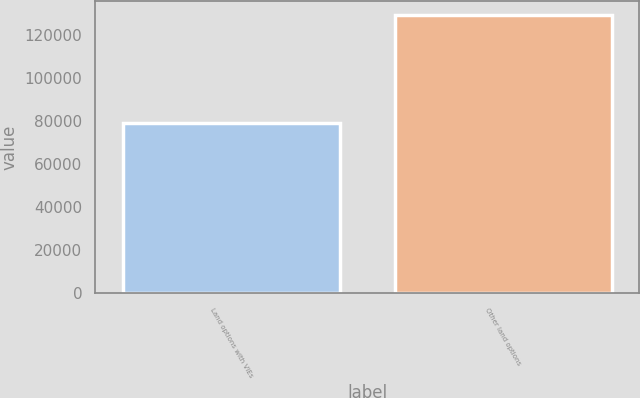Convert chart to OTSL. <chart><loc_0><loc_0><loc_500><loc_500><bar_chart><fcel>Land options with VIEs<fcel>Other land options<nl><fcel>78889<fcel>129098<nl></chart> 